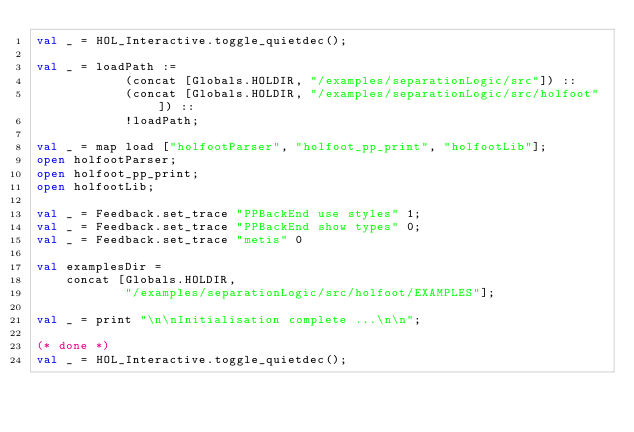<code> <loc_0><loc_0><loc_500><loc_500><_SML_>val _ = HOL_Interactive.toggle_quietdec();

val _ = loadPath :=
            (concat [Globals.HOLDIR, "/examples/separationLogic/src"]) ::
            (concat [Globals.HOLDIR, "/examples/separationLogic/src/holfoot"]) ::
            !loadPath;

val _ = map load ["holfootParser", "holfoot_pp_print", "holfootLib"];
open holfootParser;
open holfoot_pp_print;
open holfootLib;

val _ = Feedback.set_trace "PPBackEnd use styles" 1;
val _ = Feedback.set_trace "PPBackEnd show types" 0;
val _ = Feedback.set_trace "metis" 0

val examplesDir =
    concat [Globals.HOLDIR,
            "/examples/separationLogic/src/holfoot/EXAMPLES"];

val _ = print "\n\nInitialisation complete ...\n\n";

(* done *)
val _ = HOL_Interactive.toggle_quietdec();
</code> 